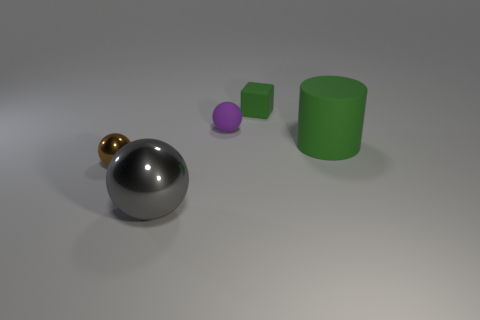The purple object that is the same shape as the small brown metal thing is what size?
Offer a very short reply. Small. Are there any small rubber blocks on the left side of the small block?
Offer a very short reply. No. What material is the big green cylinder?
Offer a terse response. Rubber. Does the rubber object right of the block have the same color as the small block?
Provide a short and direct response. Yes. Is there anything else that is the same shape as the brown metal thing?
Keep it short and to the point. Yes. What color is the other tiny thing that is the same shape as the purple matte thing?
Your answer should be compact. Brown. What is the material of the green thing that is to the left of the cylinder?
Give a very brief answer. Rubber. What is the color of the tiny matte cube?
Your response must be concise. Green. Is the size of the green rubber thing that is behind the rubber ball the same as the big gray metallic sphere?
Make the answer very short. No. What material is the thing in front of the metallic thing on the left side of the metal ball in front of the brown ball?
Provide a succinct answer. Metal. 